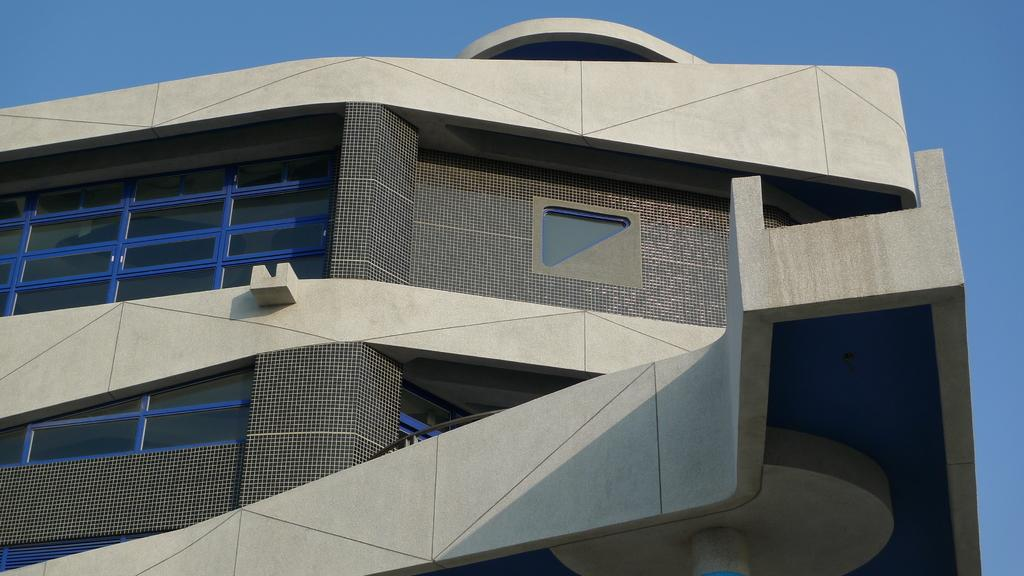What type of structure is present in the image? There is a building in the image. What part of the natural environment is visible in the image? The sky is visible in the image. What type of tool is being used to milk the cow in the image? There is no cow or milking tool present in the image; it only features a building and the sky. 